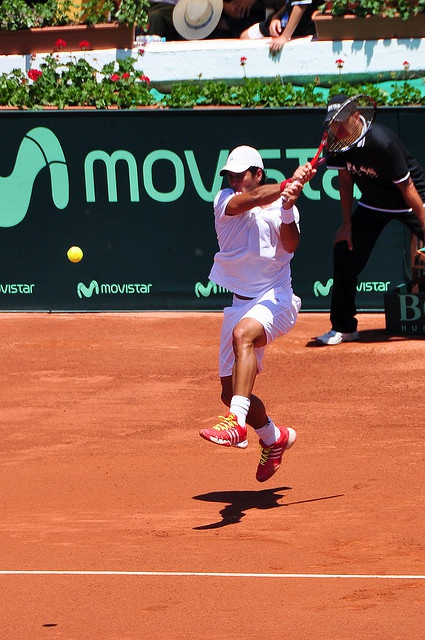Describe the objects in this image and their specific colors. I can see people in black, salmon, violet, and white tones, people in black, maroon, and gray tones, tennis racket in black, maroon, gray, and brown tones, people in black, white, salmon, and lightpink tones, and people in black, maroon, gray, and darkgreen tones in this image. 